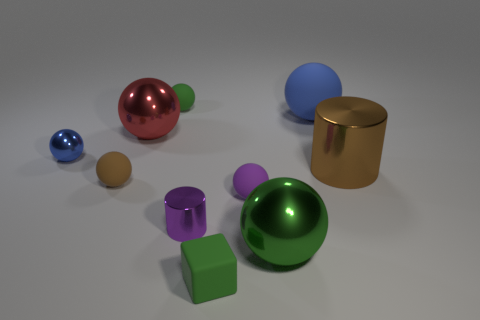Subtract all small green rubber spheres. How many spheres are left? 6 Subtract all red balls. How many balls are left? 6 Subtract all blocks. How many objects are left? 9 Subtract 5 balls. How many balls are left? 2 Subtract all red objects. Subtract all small purple rubber balls. How many objects are left? 8 Add 5 big cylinders. How many big cylinders are left? 6 Add 6 small matte cubes. How many small matte cubes exist? 7 Subtract 1 brown balls. How many objects are left? 9 Subtract all green cylinders. Subtract all purple balls. How many cylinders are left? 2 Subtract all red cubes. How many blue balls are left? 2 